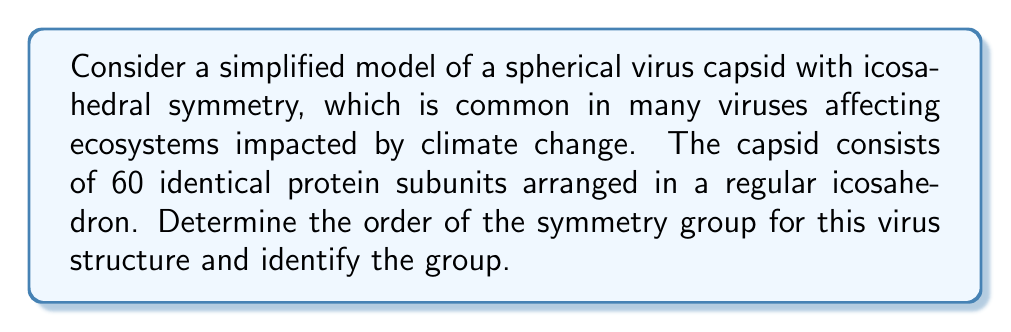Teach me how to tackle this problem. To determine the symmetry group of this virus structure, we need to consider the symmetries of a regular icosahedron:

1. Rotational symmetries:
   - 15 two-fold rotation axes (through the midpoints of edges)
   - 10 three-fold rotation axes (through vertices)
   - 6 five-fold rotation axes (through centers of faces)

2. Reflection symmetries:
   - 15 planes of reflection

3. The identity transformation

To calculate the order of the symmetry group:

1. Count the rotations:
   - Identity: 1
   - Two-fold rotations: 15 × 1 = 15
   - Three-fold rotations: 10 × 2 = 20
   - Five-fold rotations: 6 × 4 = 24

2. Total number of rotations: 1 + 15 + 20 + 24 = 60

3. The full symmetry group includes both rotations and reflections, so we double the number of rotations:
   60 × 2 = 120

The symmetry group of the icosahedron is isomorphic to the direct product of the alternating group $A_5$ and the cyclic group of order 2, denoted as $A_5 \times C_2$. This group is also known as the full icosahedral group or Ih.

Properties of this group:
- Order: 120
- It is the largest of the point groups in three dimensions
- It contains 10 conjugacy classes
- It has 5 irreducible representations

The significance of this symmetry in virology:
Icosahedral symmetry allows viruses to maximize their internal volume while minimizing the number of protein subunits required for the capsid. This efficiency in structure may contribute to the virus's ability to adapt to changing environmental conditions, potentially impacting the spread of infectious diseases in ecosystems affected by global warming.
Answer: The symmetry group of the virus capsid structure is the full icosahedral group (Ih), isomorphic to $A_5 \times C_2$, with order 120. 